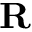Convert formula to latex. <formula><loc_0><loc_0><loc_500><loc_500>R</formula> 